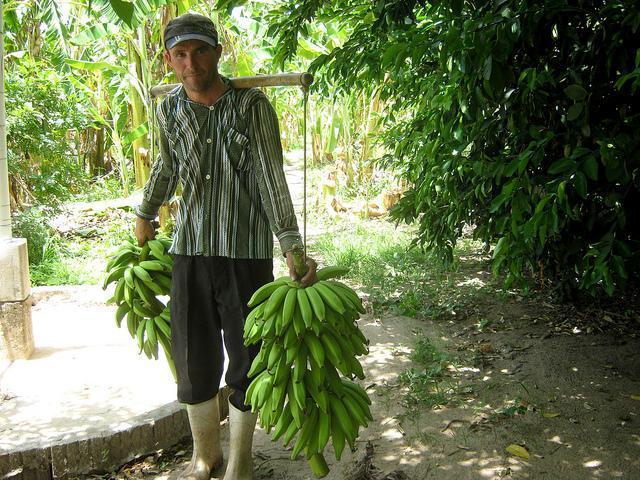How many bananas can be seen?
Give a very brief answer. 2. How many of the airplanes have entrails?
Give a very brief answer. 0. 